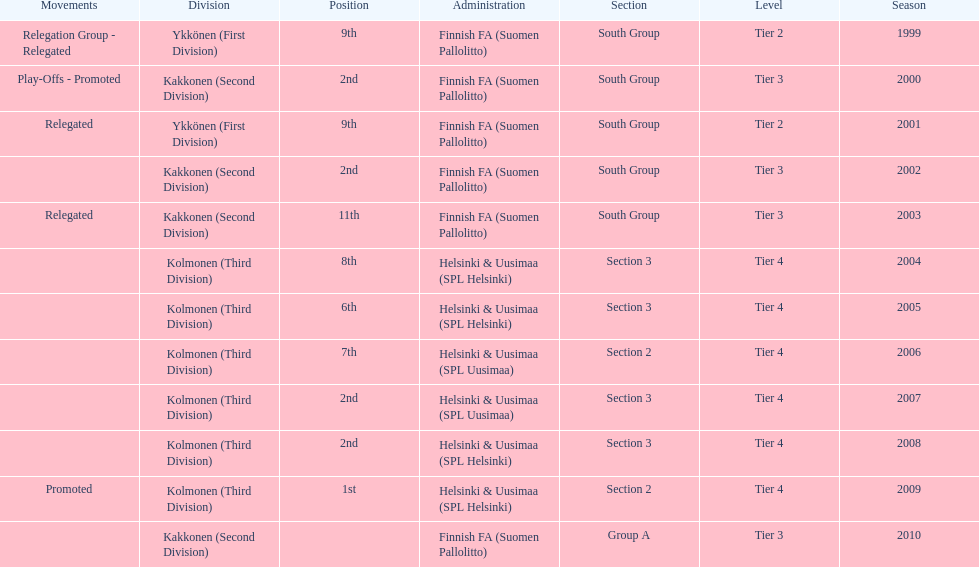How many times were they in tier 3? 4. 